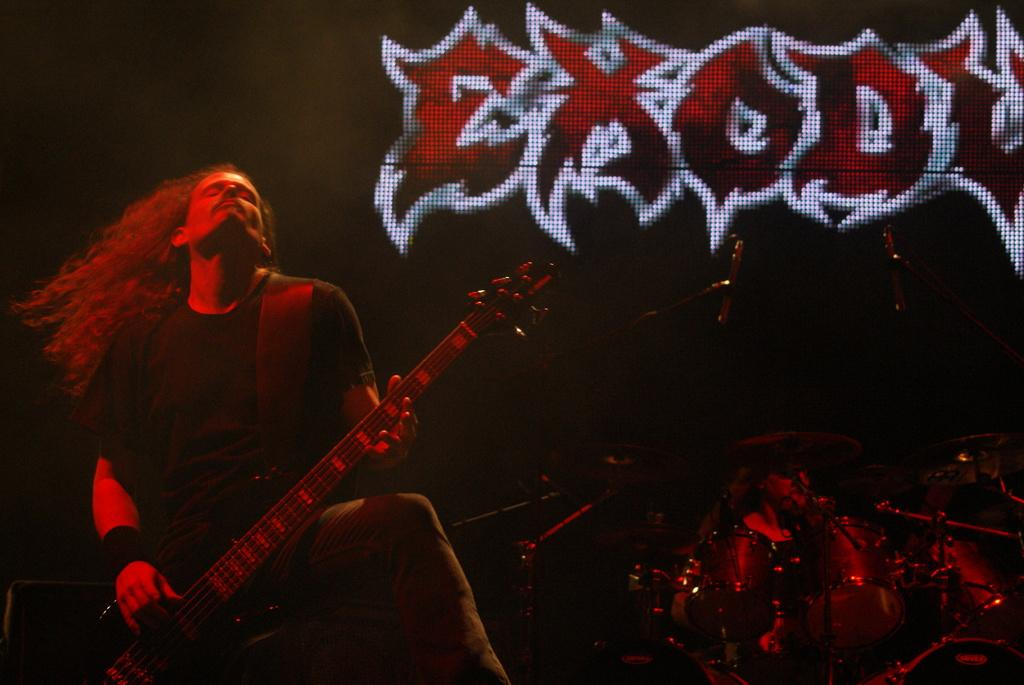Who is the main subject in the image? There is a man in the image. What is the man doing in the image? The man is standing and playing a guitar. What can be seen in the background of the image? There is a screen in the background of the image. What type of glue is the man using to attach the guide to the bucket in the image? There is no glue, guide, or bucket present in the image. 